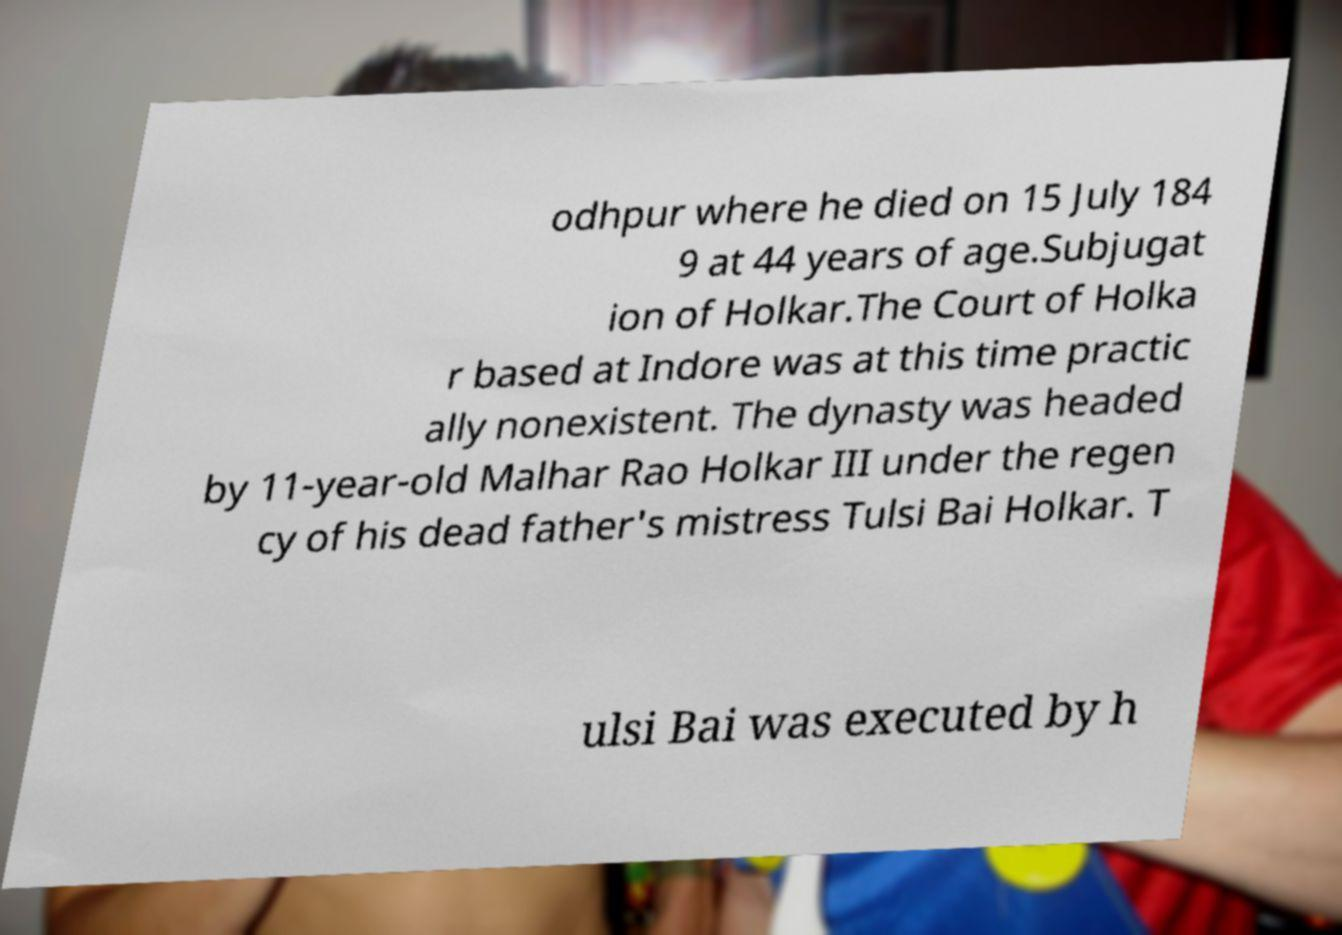What messages or text are displayed in this image? I need them in a readable, typed format. odhpur where he died on 15 July 184 9 at 44 years of age.Subjugat ion of Holkar.The Court of Holka r based at Indore was at this time practic ally nonexistent. The dynasty was headed by 11-year-old Malhar Rao Holkar III under the regen cy of his dead father's mistress Tulsi Bai Holkar. T ulsi Bai was executed by h 